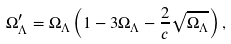Convert formula to latex. <formula><loc_0><loc_0><loc_500><loc_500>\Omega _ { \Lambda } ^ { \prime } = \Omega _ { \Lambda } \left ( 1 - 3 \Omega _ { \Lambda } - \frac { 2 } { c } \sqrt { \Omega _ { \Lambda } } \right ) ,</formula> 